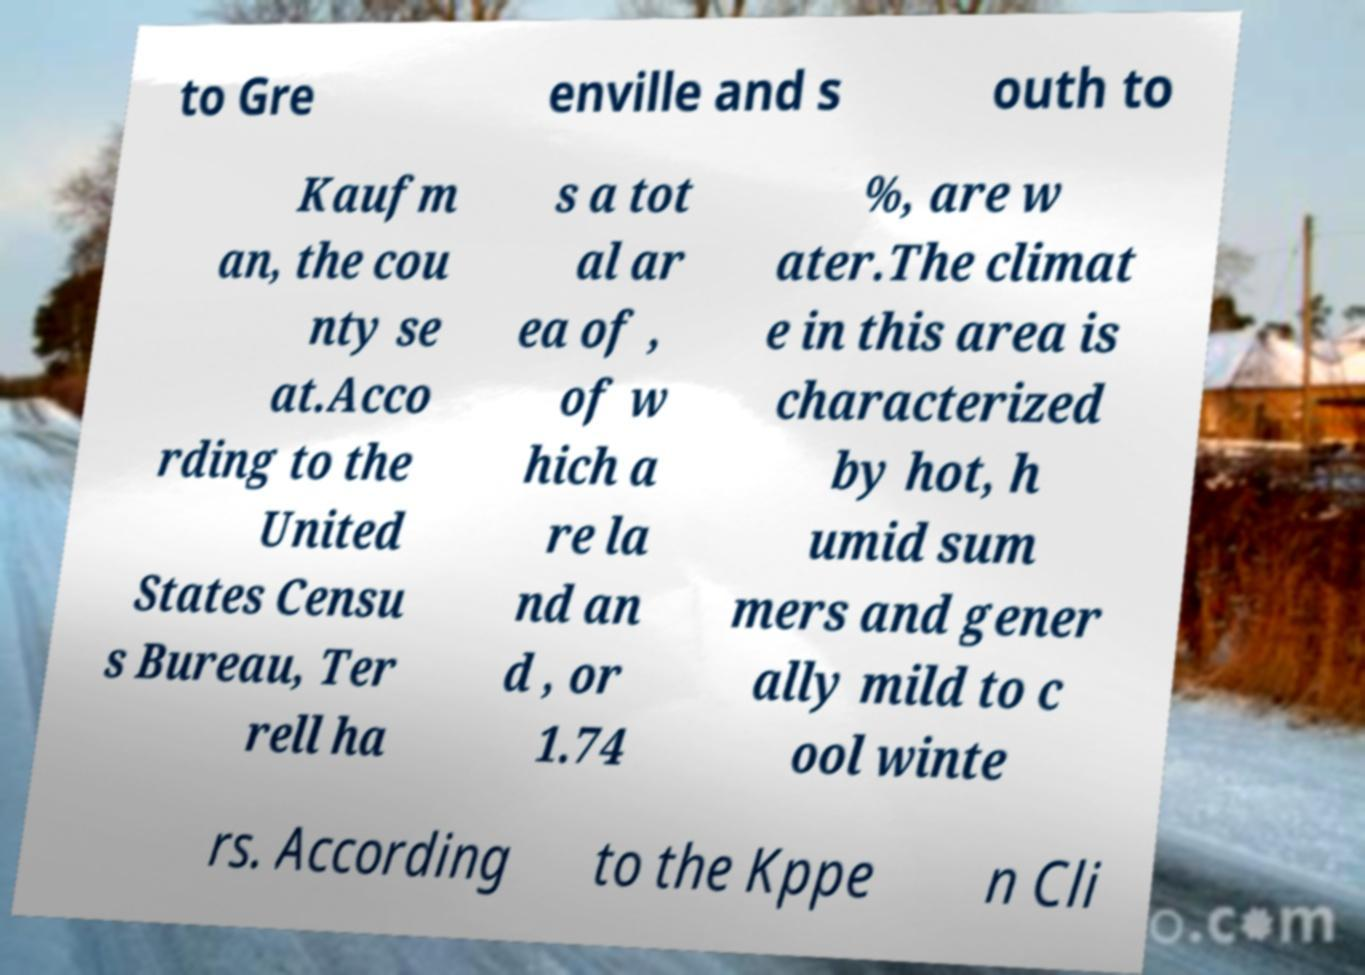Can you accurately transcribe the text from the provided image for me? to Gre enville and s outh to Kaufm an, the cou nty se at.Acco rding to the United States Censu s Bureau, Ter rell ha s a tot al ar ea of , of w hich a re la nd an d , or 1.74 %, are w ater.The climat e in this area is characterized by hot, h umid sum mers and gener ally mild to c ool winte rs. According to the Kppe n Cli 